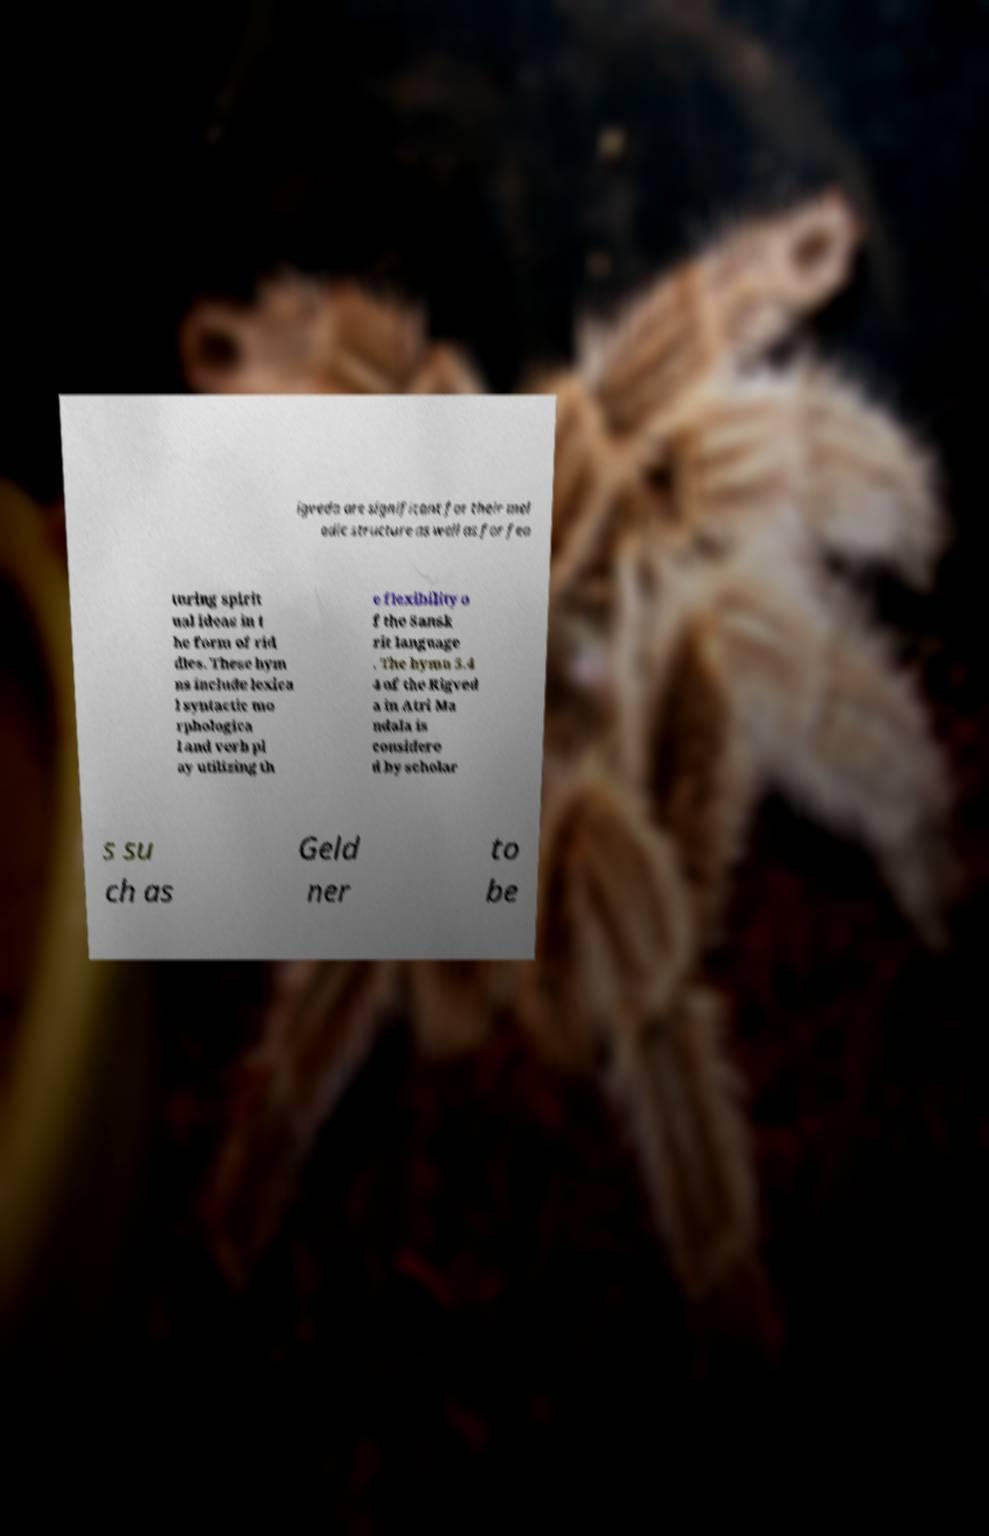For documentation purposes, I need the text within this image transcribed. Could you provide that? igveda are significant for their mel odic structure as well as for fea turing spirit ual ideas in t he form of rid dles. These hym ns include lexica l syntactic mo rphologica l and verb pl ay utilizing th e flexibility o f the Sansk rit language . The hymn 5.4 4 of the Rigved a in Atri Ma ndala is considere d by scholar s su ch as Geld ner to be 